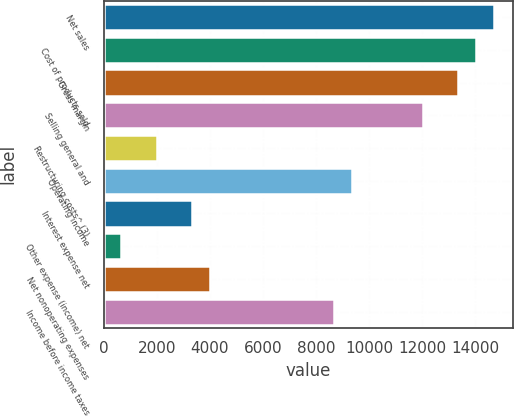<chart> <loc_0><loc_0><loc_500><loc_500><bar_chart><fcel>Net sales<fcel>Cost of products sold<fcel>Gross margin<fcel>Selling general and<fcel>Restructuring costs^ (3)<fcel>Operating income<fcel>Interest expense net<fcel>Other expense (income) net<fcel>Net nonoperating expenses<fcel>Income before income taxes<nl><fcel>14701.5<fcel>14033.2<fcel>13365<fcel>12028.6<fcel>2005.47<fcel>9355.78<fcel>3341.89<fcel>669.05<fcel>4010.1<fcel>8687.57<nl></chart> 